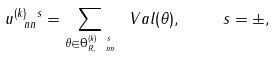Convert formula to latex. <formula><loc_0><loc_0><loc_500><loc_500>u ^ { ( k ) \ s } _ { \ n n } = \sum _ { \theta \in \Theta _ { R , \ n n } ^ { ( k ) \ s } } \ V a l ( \theta ) , \quad \ s = \pm ,</formula> 